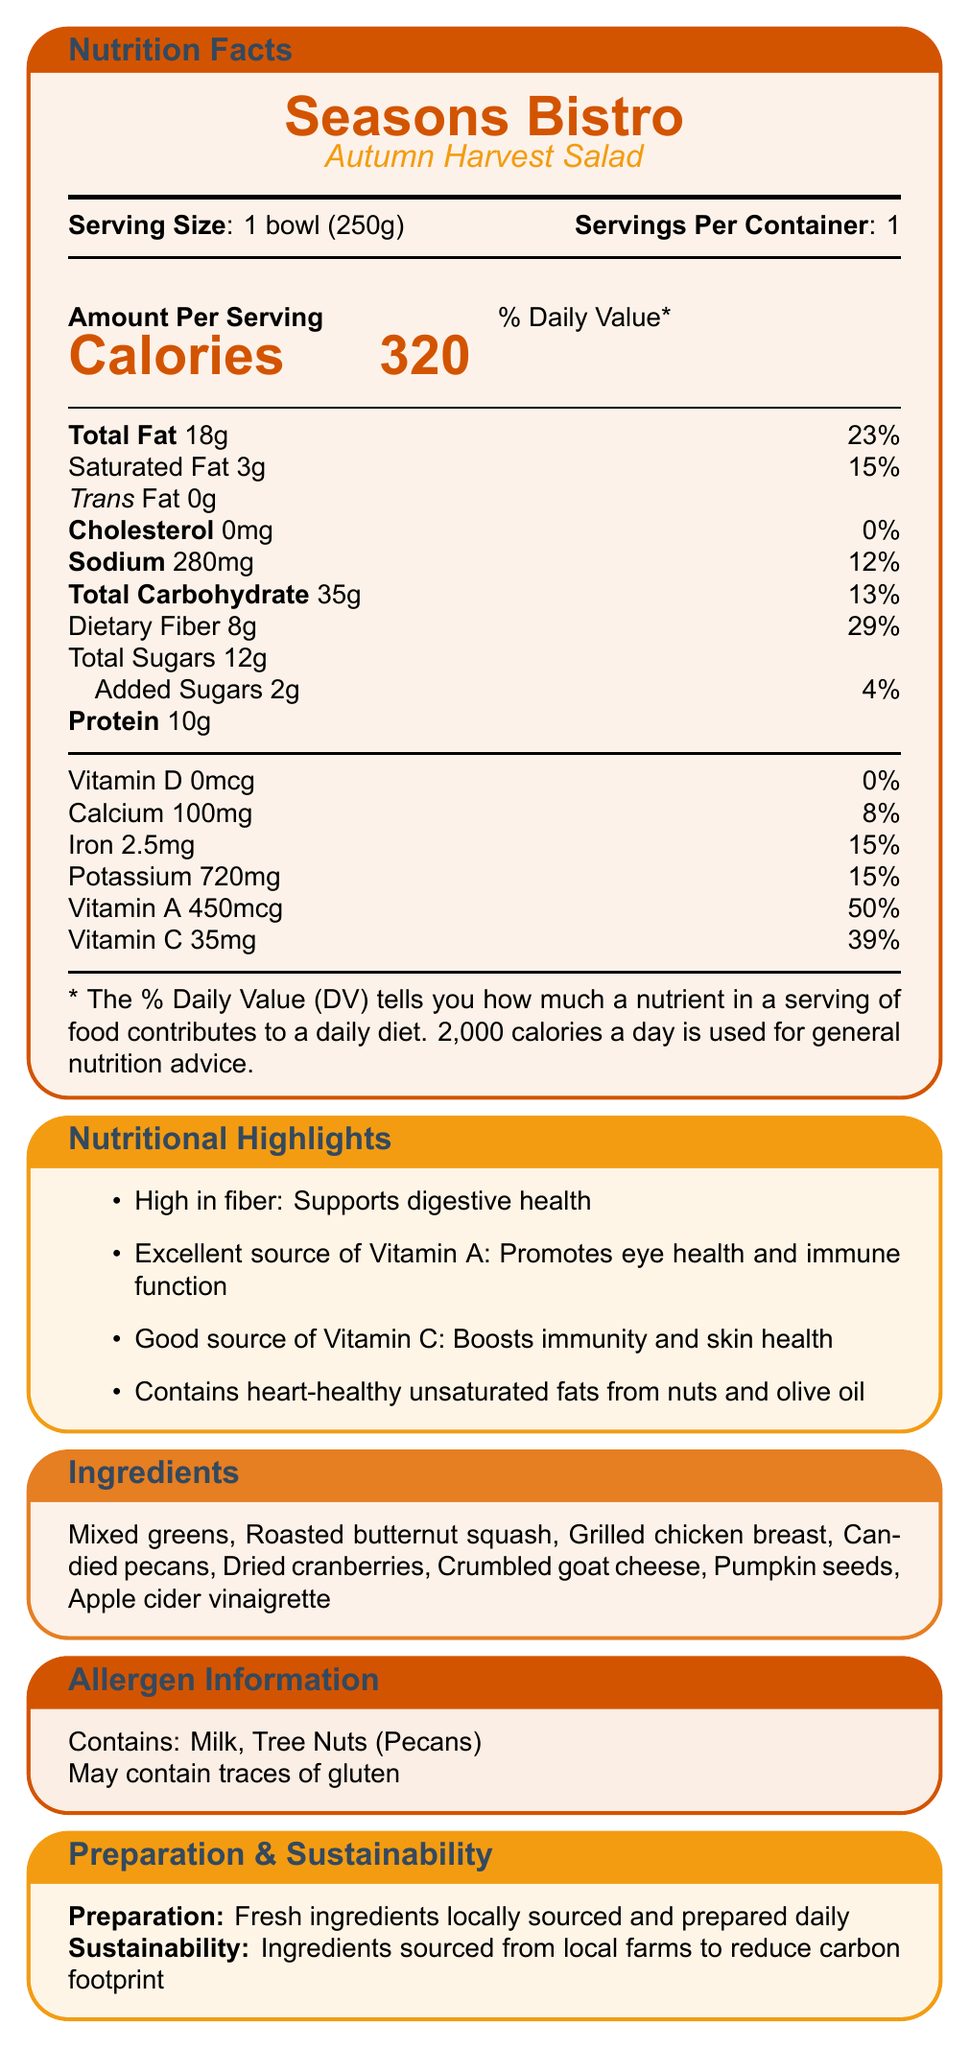How many calories are in one serving of the Autumn Harvest Salad? The document states that there are 320 calories per serving.
Answer: 320 What is the percentage of daily value for dietary fiber? The document lists dietary fiber as providing 29% of the daily value.
Answer: 29% What ingredients are included in the Autumn Harvest Salad? The ingredients are listed in the document under the "Ingredients" section.
Answer: Mixed greens, Roasted butternut squash, Grilled chicken breast, Candied pecans, Dried cranberries, Crumbled goat cheese, Pumpkin seeds, Apple cider vinaigrette What sustainability practices does Seasons Bistro follow regarding their Autumn Harvest Salad? The preparation and sustainability note states the ingredients are sourced from local farms.
Answer: Ingredients sourced from local farms to reduce carbon footprint What vitamins are prominently featured in the nutritional highlights? The document highlights Vitamin A and Vitamin C as key nutrients. Vitamin A promotes eye health and immune function, while Vitamin C boosts immunity and skin health.
Answer: Vitamin A and Vitamin C Which nutrient does the Autumn Harvest Salad provide 50% of the daily value? A. Vitamin A B. Vitamin C C. Iron D. Calcium The document states that the salad provides 50% of the daily value for Vitamin A.
Answer: A. Vitamin A Which nutrient is not present in the Autumn Harvest Salad? 1. Vitamin D 2. Sodium 3. Calcium 4. Protein The document indicates that Vitamin D is 0mcg, which is 0% of the daily value.
Answer: 1. Vitamin D Does the Autumn Harvest Salad contain trans fat? The document states that the trans fat content is 0g.
Answer: No Is the Autumn Harvest Salad suitable for individuals with nut allergies? The document states it contains tree nuts (pecans) and may contain traces of gluten.
Answer: No Summarize the main nutritional highlights and key ingredients of the Autumn Harvest Salad. The summary includes the primary nutritional benefits and a list of key ingredients based on the information provided in the document.
Answer: The Autumn Harvest Salad is high in fiber, an excellent source of Vitamin A, and a good source of Vitamin C. It contains heart-healthy unsaturated fats from nuts and olive oil. Key ingredients include mixed greens, roasted butternut squash, grilled chicken breast, candied pecans, dried cranberries, crumbled goat cheese, pumpkin seeds, and apple cider vinaigrette. What is the exact preparation method of the Autumn Harvest Salad? The document states that the salad is prepared with fresh ingredients sourced locally and prepared daily, but does not detail the exact preparation steps.
Answer: Not enough information 